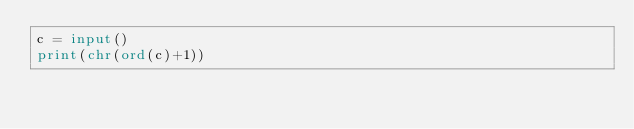Convert code to text. <code><loc_0><loc_0><loc_500><loc_500><_Python_>c = input()
print(chr(ord(c)+1))</code> 